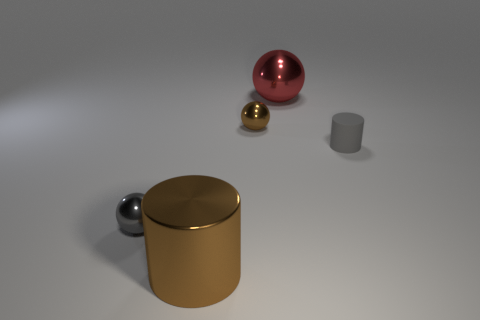What size is the brown shiny thing behind the rubber cylinder?
Make the answer very short. Small. Is the number of large brown matte objects less than the number of large red metal spheres?
Give a very brief answer. Yes. Are the cylinder to the right of the brown cylinder and the big thing in front of the big red metallic ball made of the same material?
Give a very brief answer. No. What is the shape of the large shiny object to the left of the large metal thing that is to the right of the small metal object behind the matte object?
Ensure brevity in your answer.  Cylinder. How many gray balls are made of the same material as the small gray cylinder?
Your answer should be compact. 0. There is a gray thing that is on the right side of the large brown metal cylinder; what number of metal objects are in front of it?
Your answer should be compact. 2. There is a thing left of the brown cylinder; is its color the same as the large metallic object that is in front of the gray shiny thing?
Provide a short and direct response. No. There is a shiny object that is both on the left side of the tiny brown metallic object and behind the large brown cylinder; what shape is it?
Give a very brief answer. Sphere. Is there a tiny gray thing of the same shape as the red metallic thing?
Provide a succinct answer. Yes. There is a gray metallic object that is the same size as the gray matte thing; what shape is it?
Offer a very short reply. Sphere. 